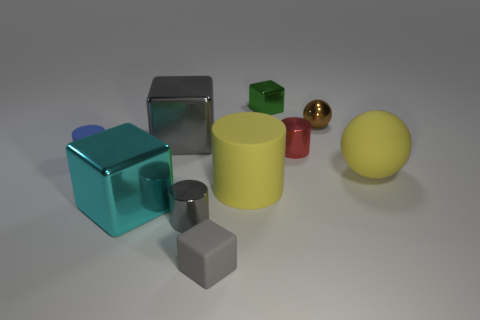Subtract all big yellow cylinders. How many cylinders are left? 3 Add 2 small blue matte things. How many small blue matte things are left? 3 Add 2 tiny yellow cylinders. How many tiny yellow cylinders exist? 2 Subtract all blue cylinders. How many cylinders are left? 3 Subtract 0 green cylinders. How many objects are left? 10 Subtract all balls. How many objects are left? 8 Subtract 2 cylinders. How many cylinders are left? 2 Subtract all green cubes. Subtract all green balls. How many cubes are left? 3 Subtract all green cylinders. How many purple cubes are left? 0 Subtract all big purple shiny cubes. Subtract all metal things. How many objects are left? 4 